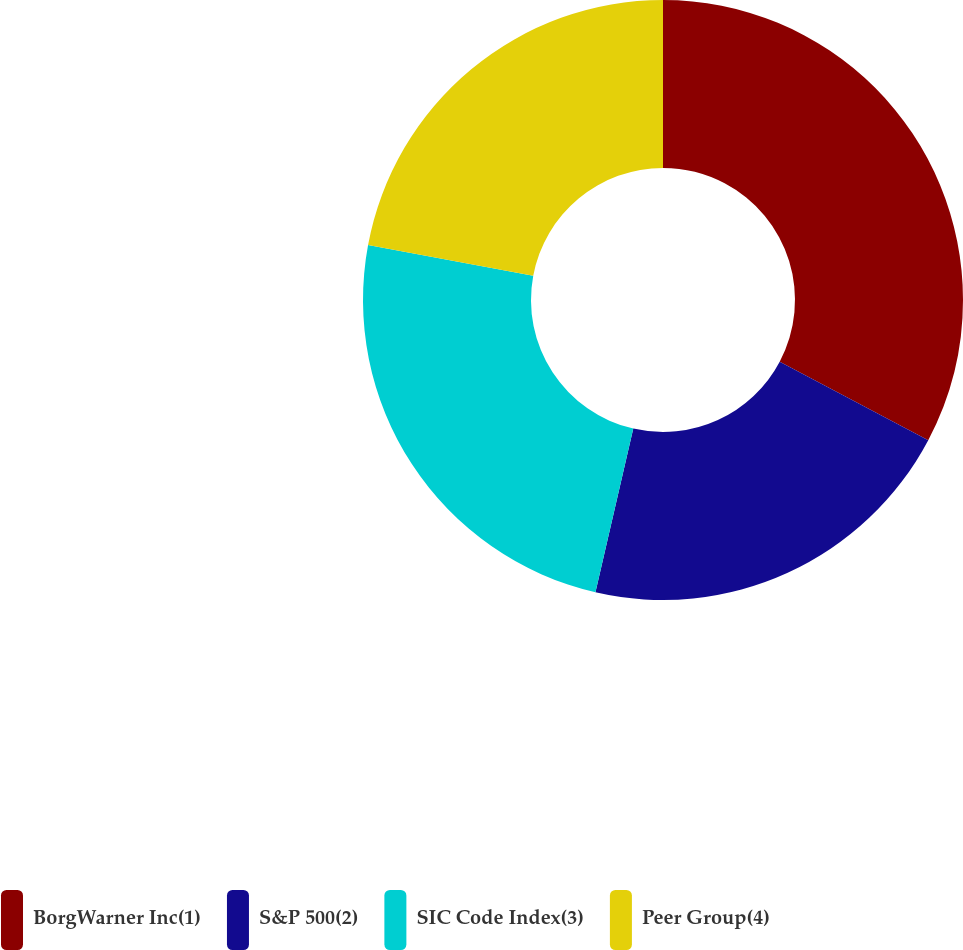Convert chart. <chart><loc_0><loc_0><loc_500><loc_500><pie_chart><fcel>BorgWarner Inc(1)<fcel>S&P 500(2)<fcel>SIC Code Index(3)<fcel>Peer Group(4)<nl><fcel>32.74%<fcel>20.88%<fcel>24.32%<fcel>22.07%<nl></chart> 